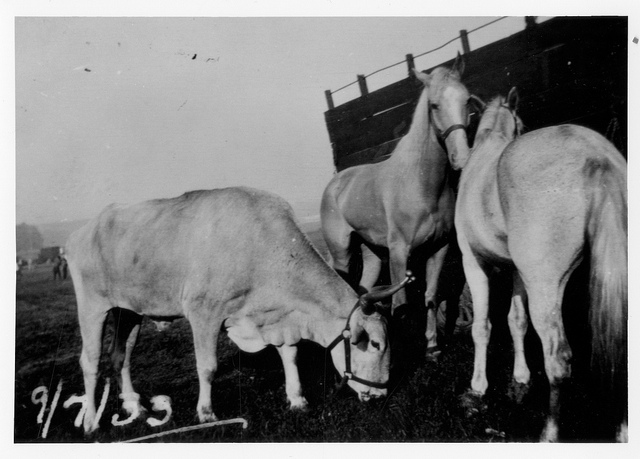Please transcribe the text in this image. 9 7 33 